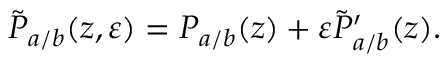Convert formula to latex. <formula><loc_0><loc_0><loc_500><loc_500>\tilde { P } _ { a / b } ( z , \varepsilon ) = P _ { a / b } ( z ) + \varepsilon \tilde { P } _ { a / b } ^ { \prime } ( z ) .</formula> 